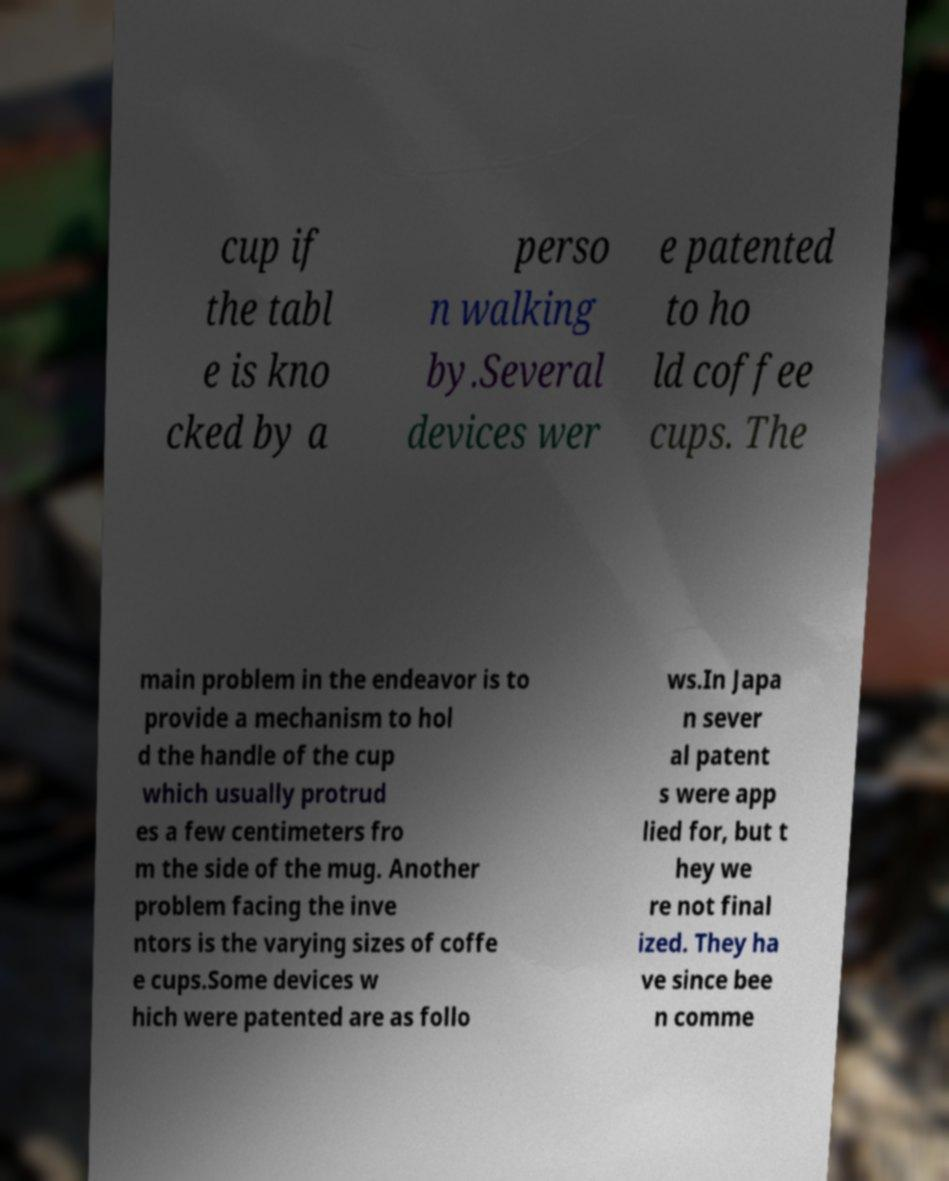Could you extract and type out the text from this image? cup if the tabl e is kno cked by a perso n walking by.Several devices wer e patented to ho ld coffee cups. The main problem in the endeavor is to provide a mechanism to hol d the handle of the cup which usually protrud es a few centimeters fro m the side of the mug. Another problem facing the inve ntors is the varying sizes of coffe e cups.Some devices w hich were patented are as follo ws.In Japa n sever al patent s were app lied for, but t hey we re not final ized. They ha ve since bee n comme 